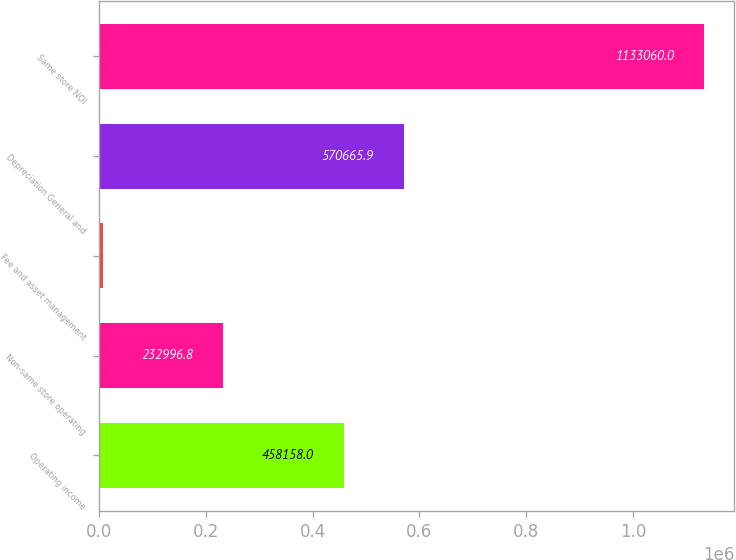Convert chart to OTSL. <chart><loc_0><loc_0><loc_500><loc_500><bar_chart><fcel>Operating income<fcel>Non-same store operating<fcel>Fee and asset management<fcel>Depreciation General and<fcel>Same store NOI<nl><fcel>458158<fcel>232997<fcel>7981<fcel>570666<fcel>1.13306e+06<nl></chart> 